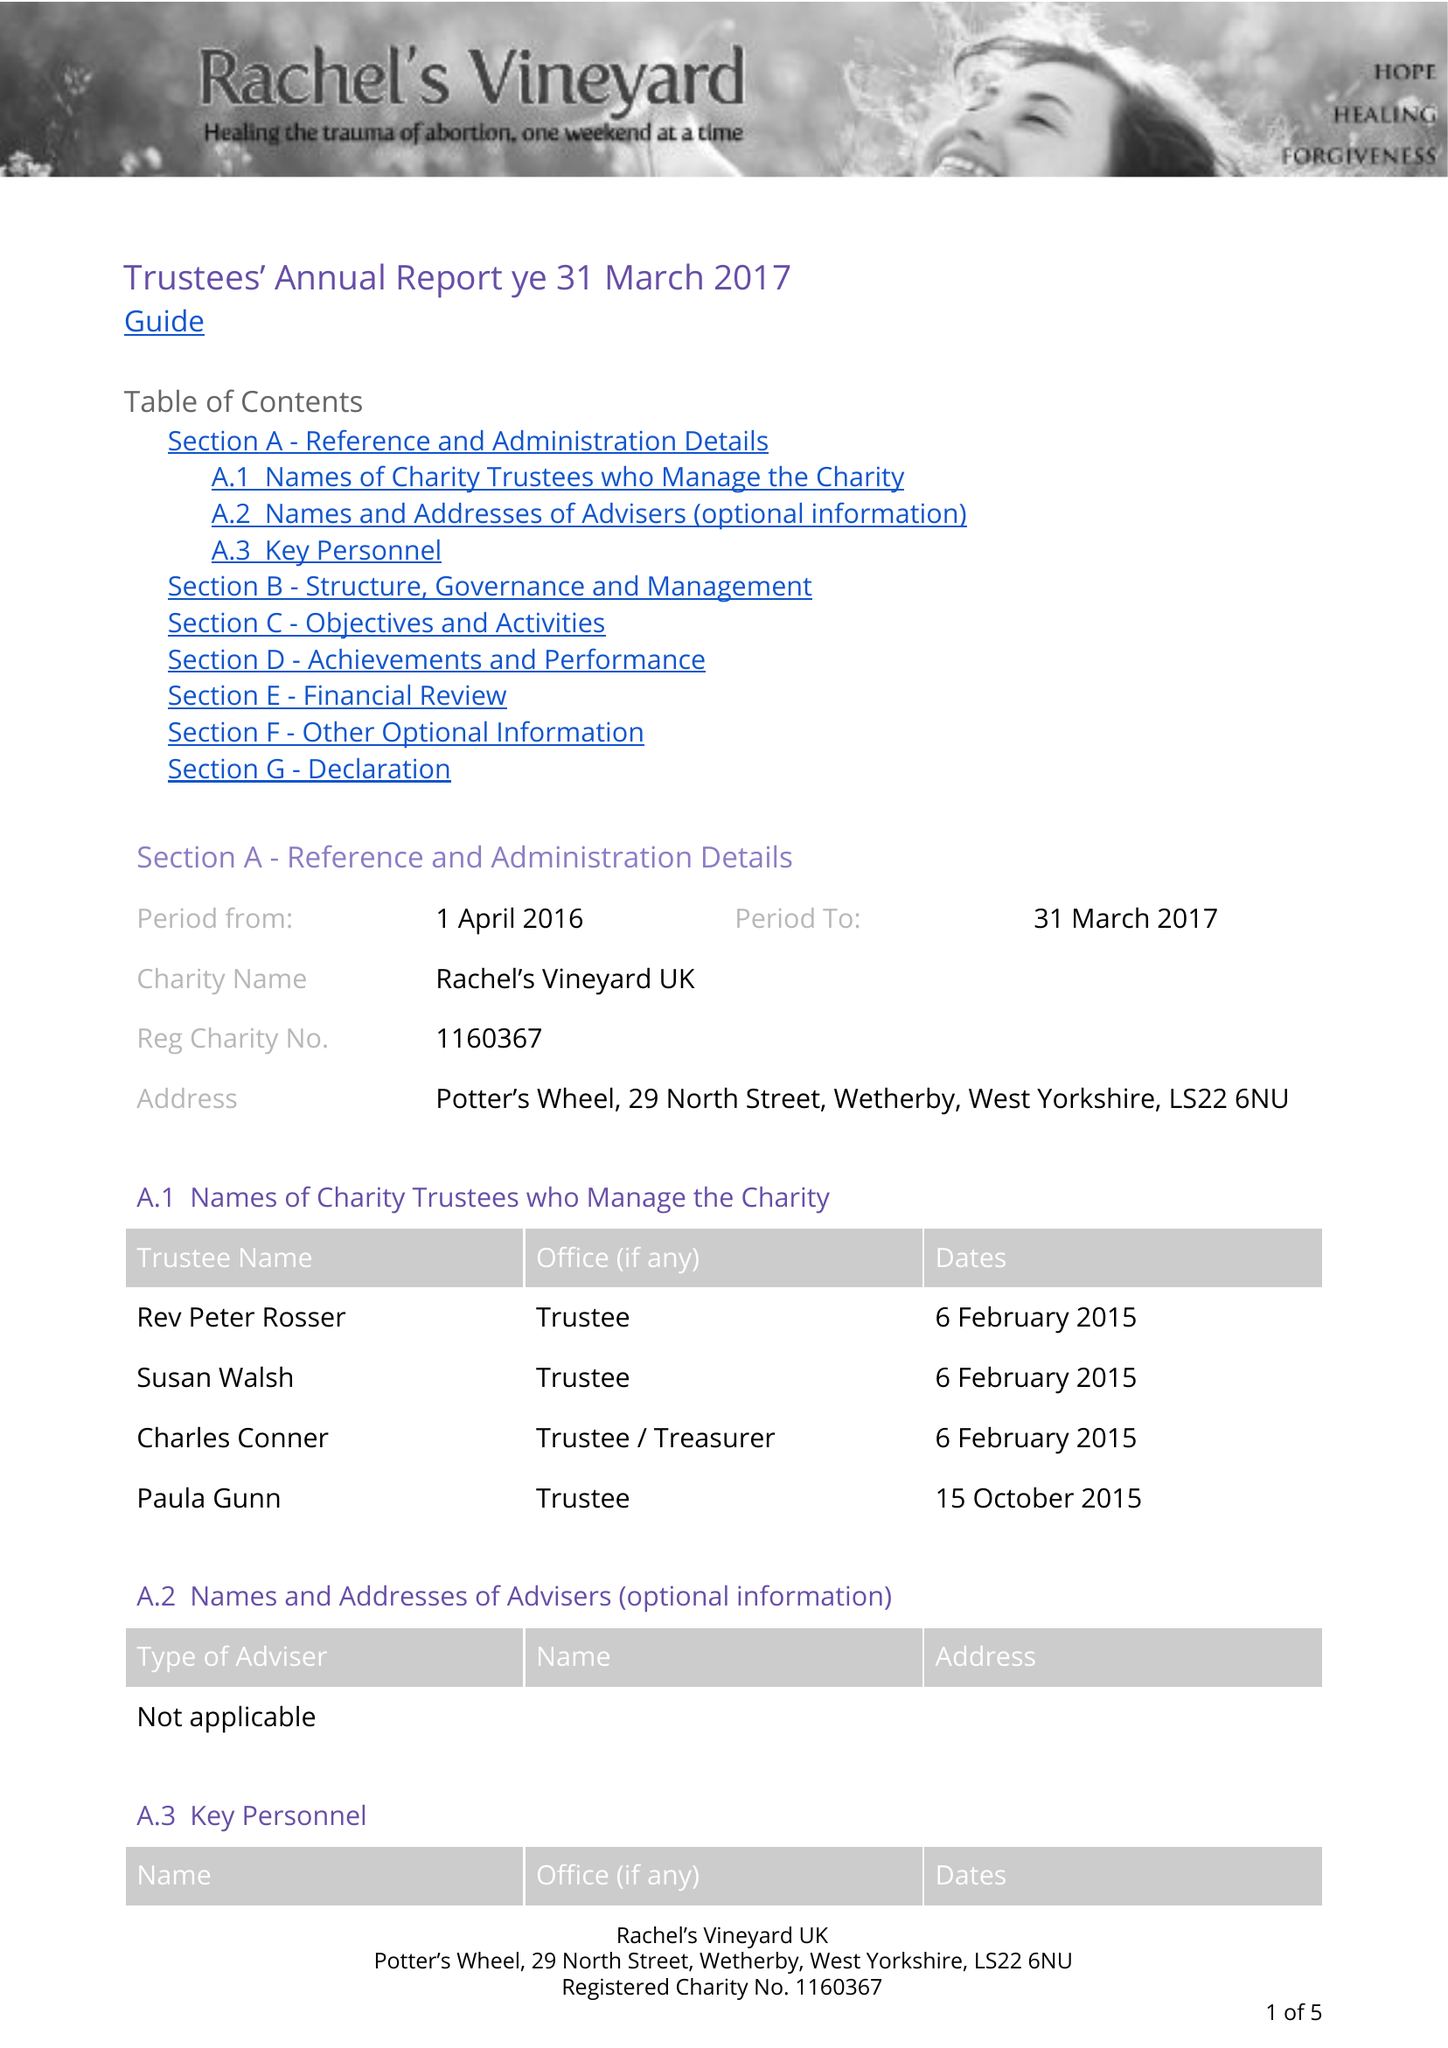What is the value for the address__street_line?
Answer the question using a single word or phrase. 29 NORTH STREET 